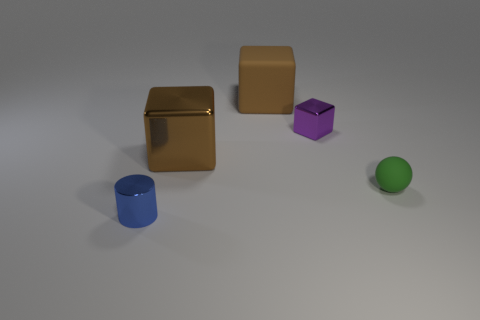Add 3 small brown rubber cylinders. How many objects exist? 8 Subtract all cylinders. How many objects are left? 4 Subtract 0 yellow cubes. How many objects are left? 5 Subtract all brown blocks. Subtract all matte balls. How many objects are left? 2 Add 2 large matte objects. How many large matte objects are left? 3 Add 2 small blocks. How many small blocks exist? 3 